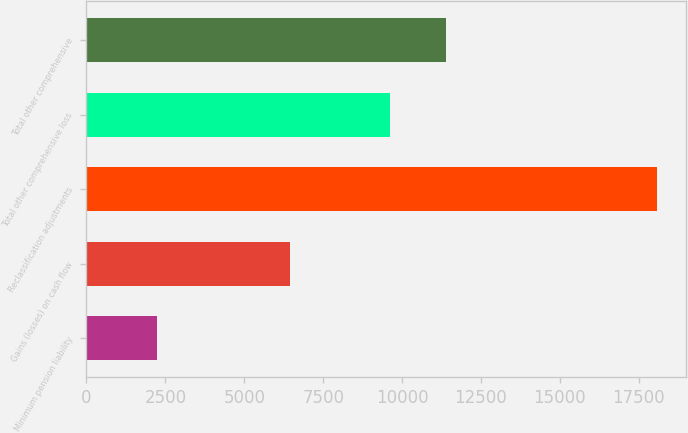Convert chart to OTSL. <chart><loc_0><loc_0><loc_500><loc_500><bar_chart><fcel>Minimum pension liability<fcel>Gains (losses) on cash flow<fcel>Reclassification adjustments<fcel>Total other comprehensive loss<fcel>Total other comprehensive<nl><fcel>2231<fcel>6464<fcel>18087<fcel>9631<fcel>11394<nl></chart> 